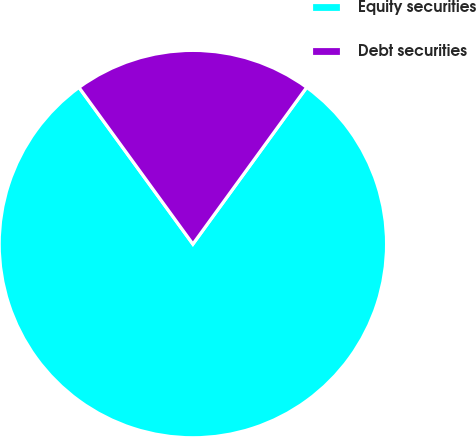<chart> <loc_0><loc_0><loc_500><loc_500><pie_chart><fcel>Equity securities<fcel>Debt securities<nl><fcel>80.0%<fcel>20.0%<nl></chart> 